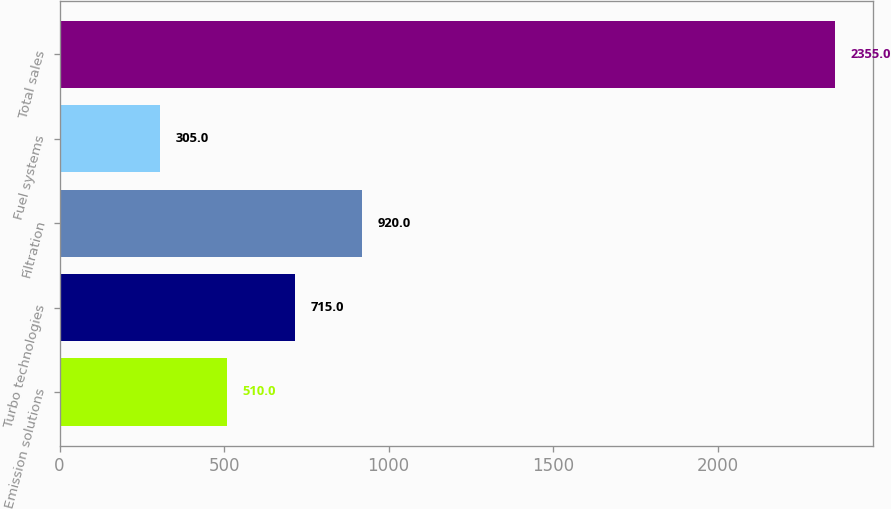Convert chart to OTSL. <chart><loc_0><loc_0><loc_500><loc_500><bar_chart><fcel>Emission solutions<fcel>Turbo technologies<fcel>Filtration<fcel>Fuel systems<fcel>Total sales<nl><fcel>510<fcel>715<fcel>920<fcel>305<fcel>2355<nl></chart> 